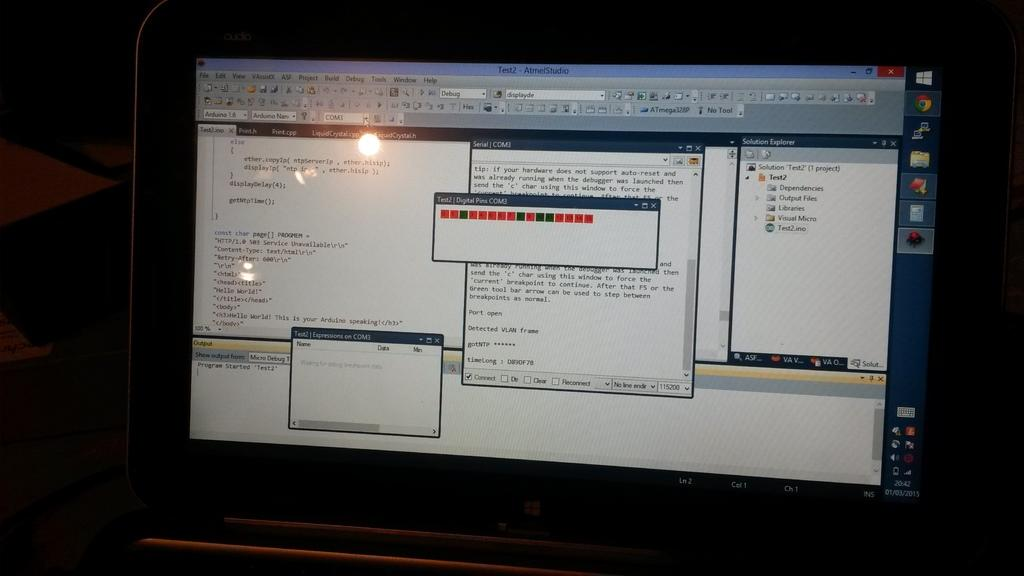<image>
Give a short and clear explanation of the subsequent image. Windows laptop monitor showing a pop up that says Test 2. 